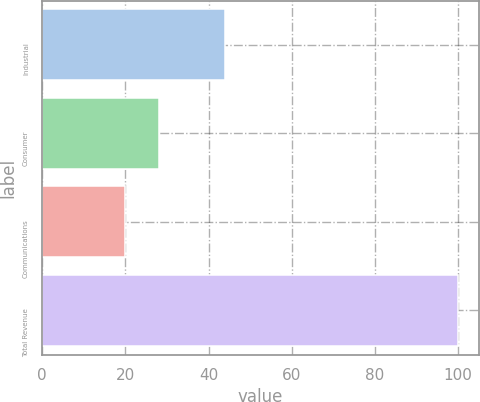<chart> <loc_0><loc_0><loc_500><loc_500><bar_chart><fcel>Industrial<fcel>Consumer<fcel>Communications<fcel>Total Revenue<nl><fcel>44<fcel>28<fcel>20<fcel>100<nl></chart> 